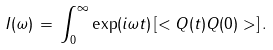<formula> <loc_0><loc_0><loc_500><loc_500>I ( \omega ) \, = \, \int _ { 0 } ^ { \infty } \exp ( i \omega t ) \left [ < Q ( t ) Q ( 0 ) > \right ] .</formula> 